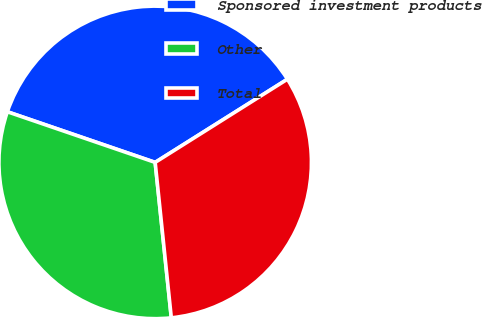Convert chart to OTSL. <chart><loc_0><loc_0><loc_500><loc_500><pie_chart><fcel>Sponsored investment products<fcel>Other<fcel>Total<nl><fcel>35.81%<fcel>31.9%<fcel>32.29%<nl></chart> 